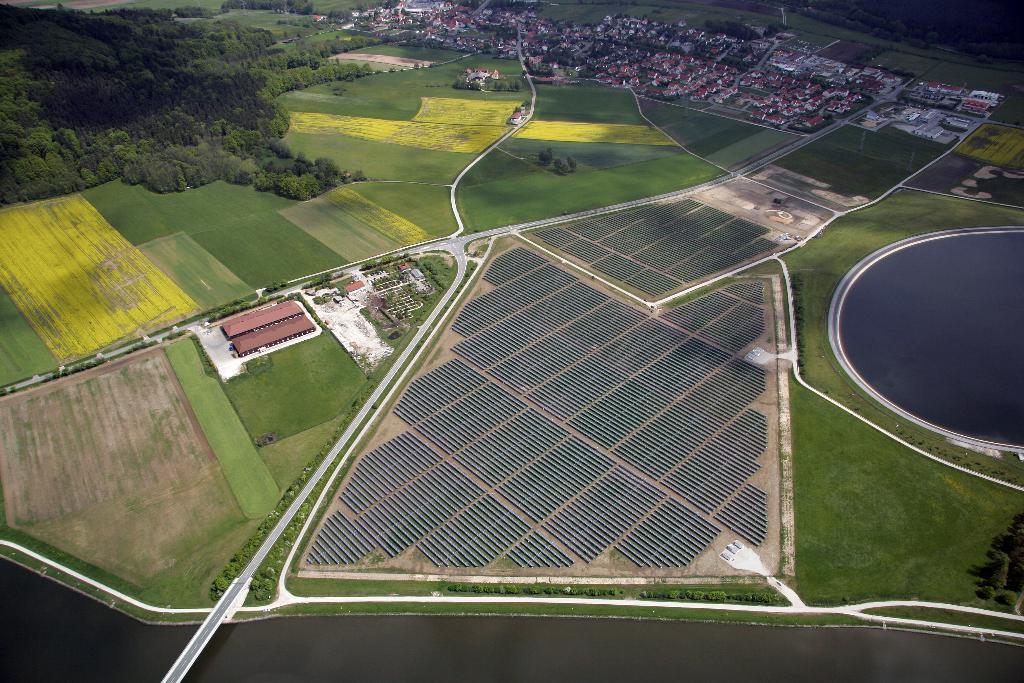Describe this image in one or two sentences. This image is clicked from the top. There are trees in the bottom left corner. There are houses at the top. There are fields all over the image. In the middle it looks like solar panels. 